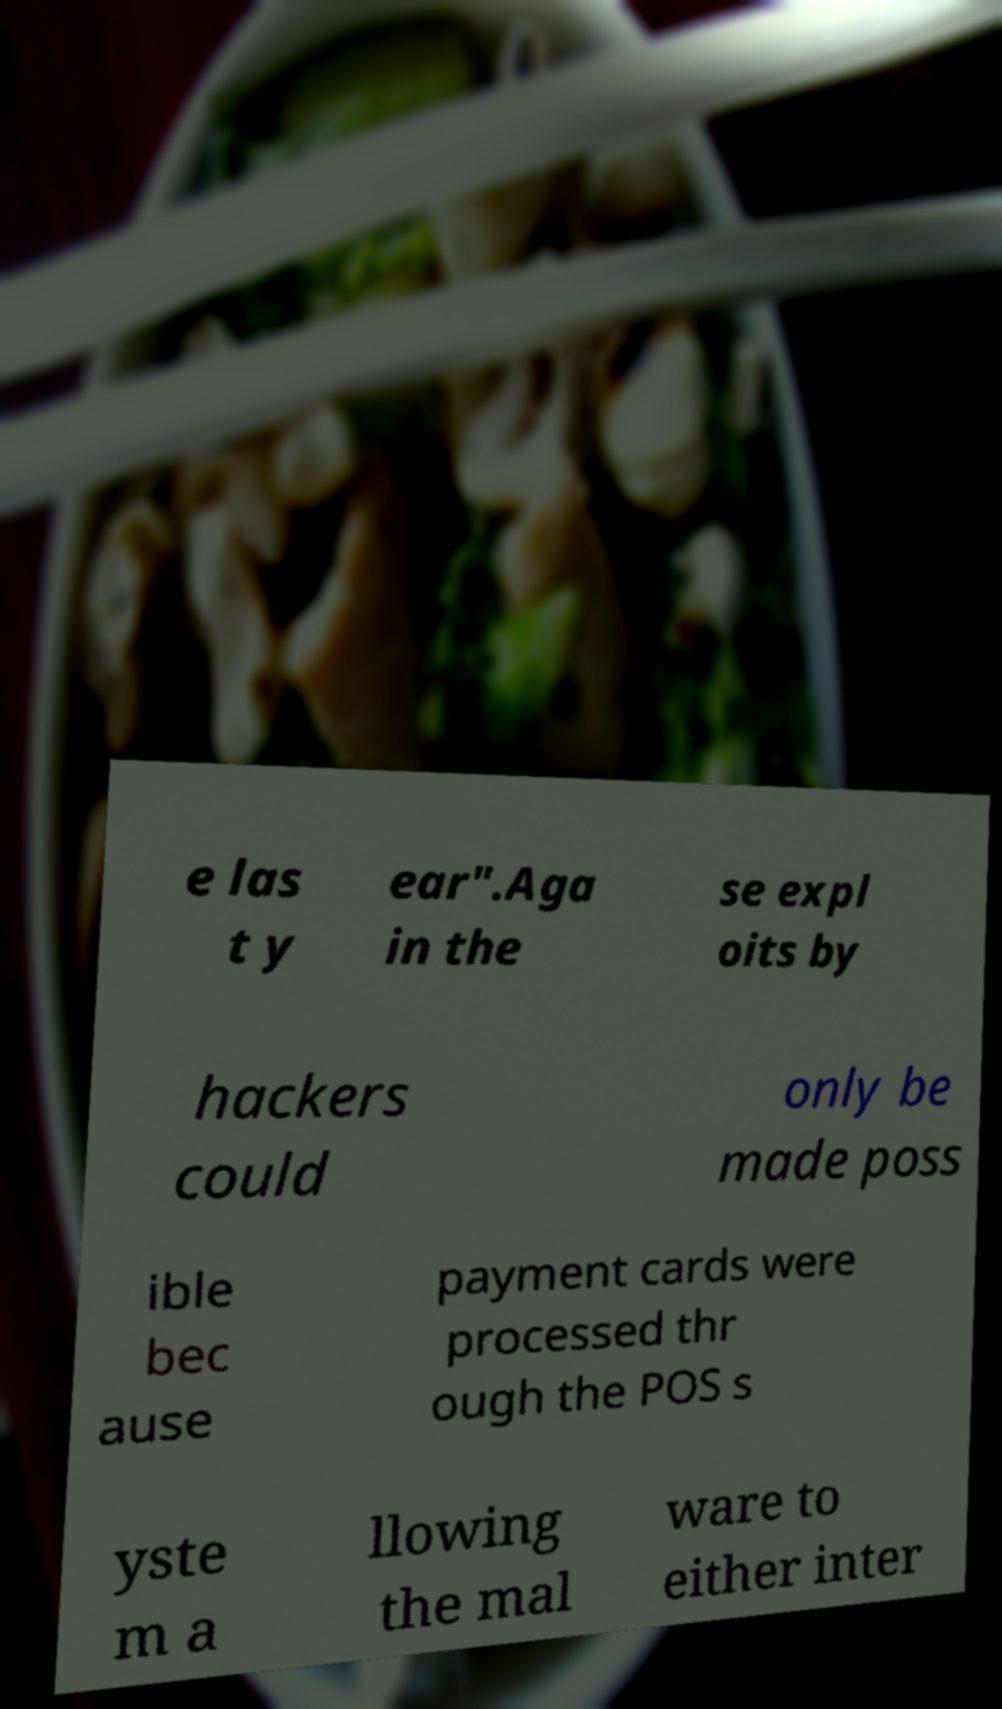Could you extract and type out the text from this image? e las t y ear".Aga in the se expl oits by hackers could only be made poss ible bec ause payment cards were processed thr ough the POS s yste m a llowing the mal ware to either inter 